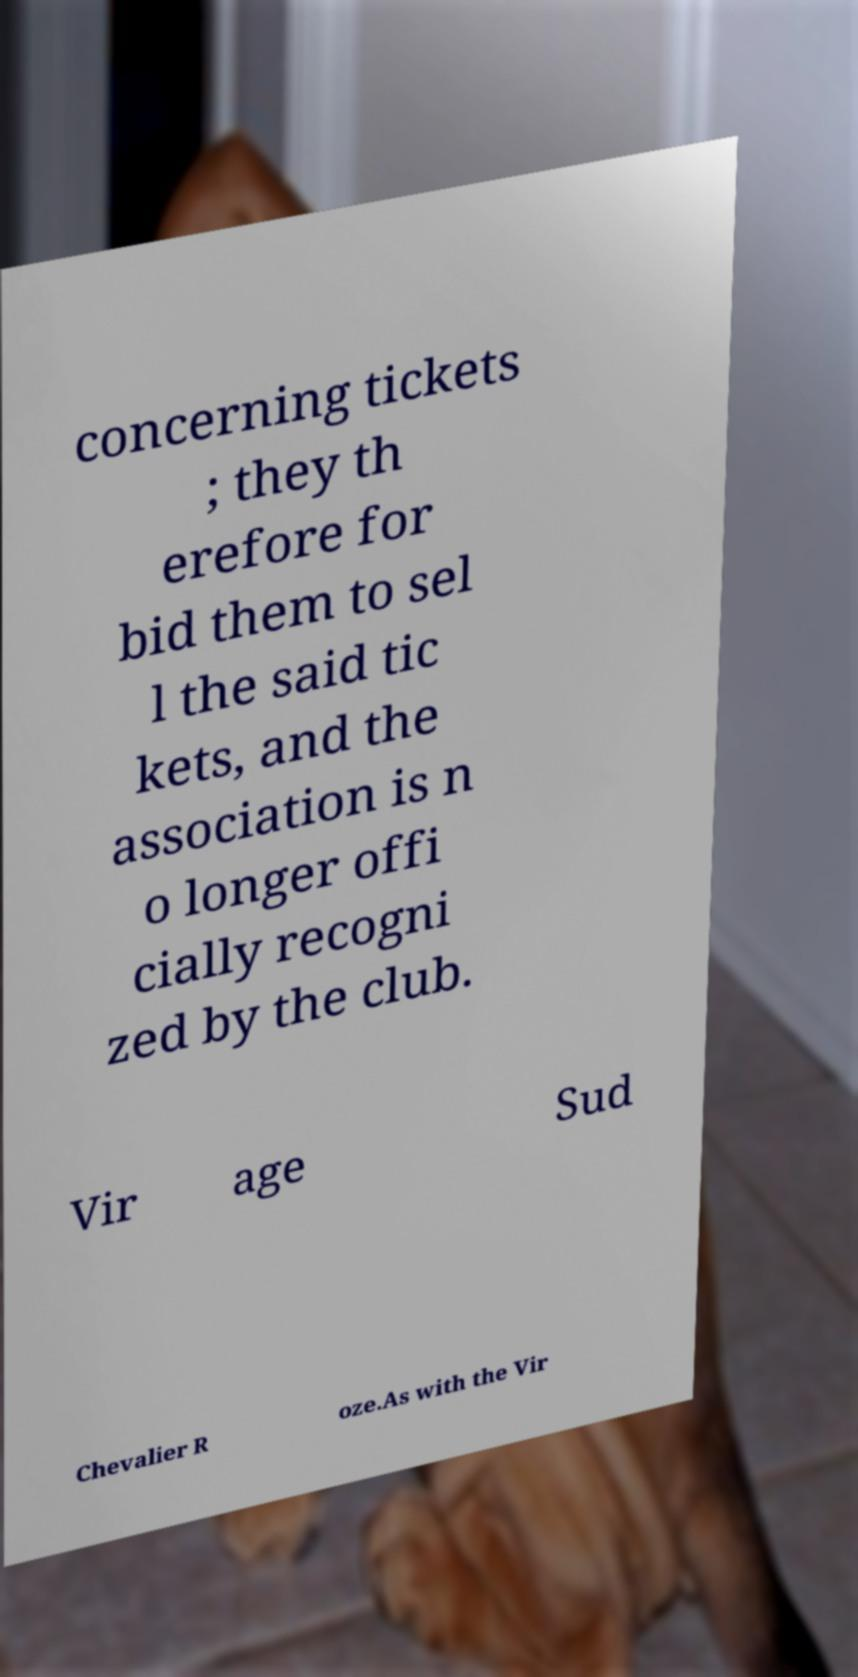Could you assist in decoding the text presented in this image and type it out clearly? concerning tickets ; they th erefore for bid them to sel l the said tic kets, and the association is n o longer offi cially recogni zed by the club. Vir age Sud Chevalier R oze.As with the Vir 